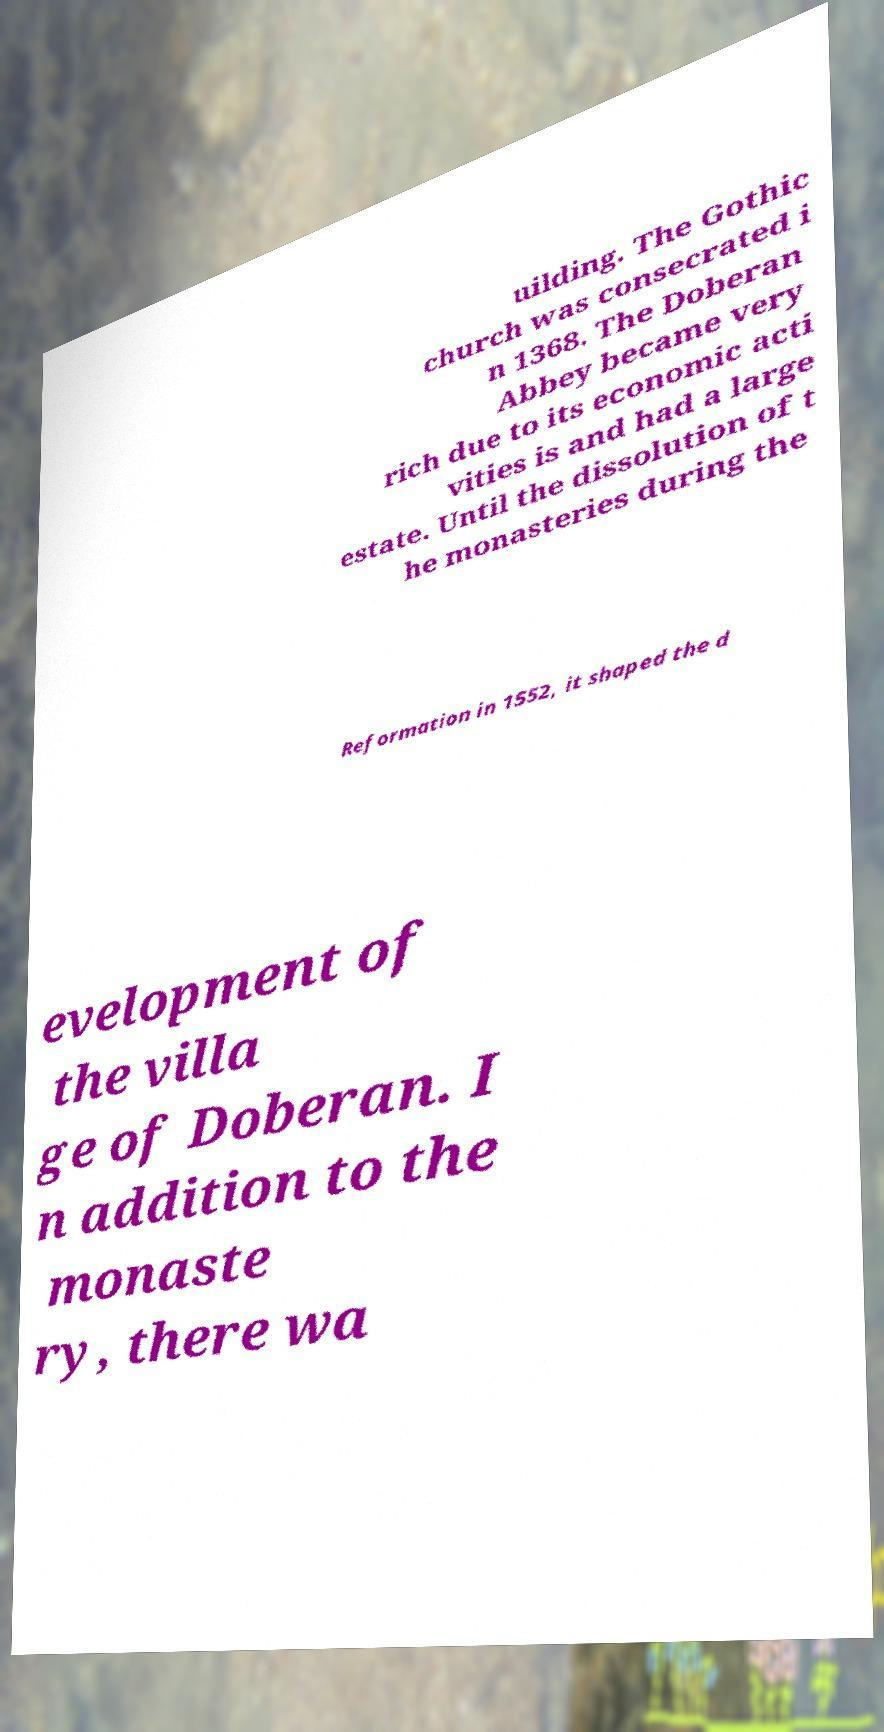Can you read and provide the text displayed in the image?This photo seems to have some interesting text. Can you extract and type it out for me? uilding. The Gothic church was consecrated i n 1368. The Doberan Abbey became very rich due to its economic acti vities is and had a large estate. Until the dissolution of t he monasteries during the Reformation in 1552, it shaped the d evelopment of the villa ge of Doberan. I n addition to the monaste ry, there wa 